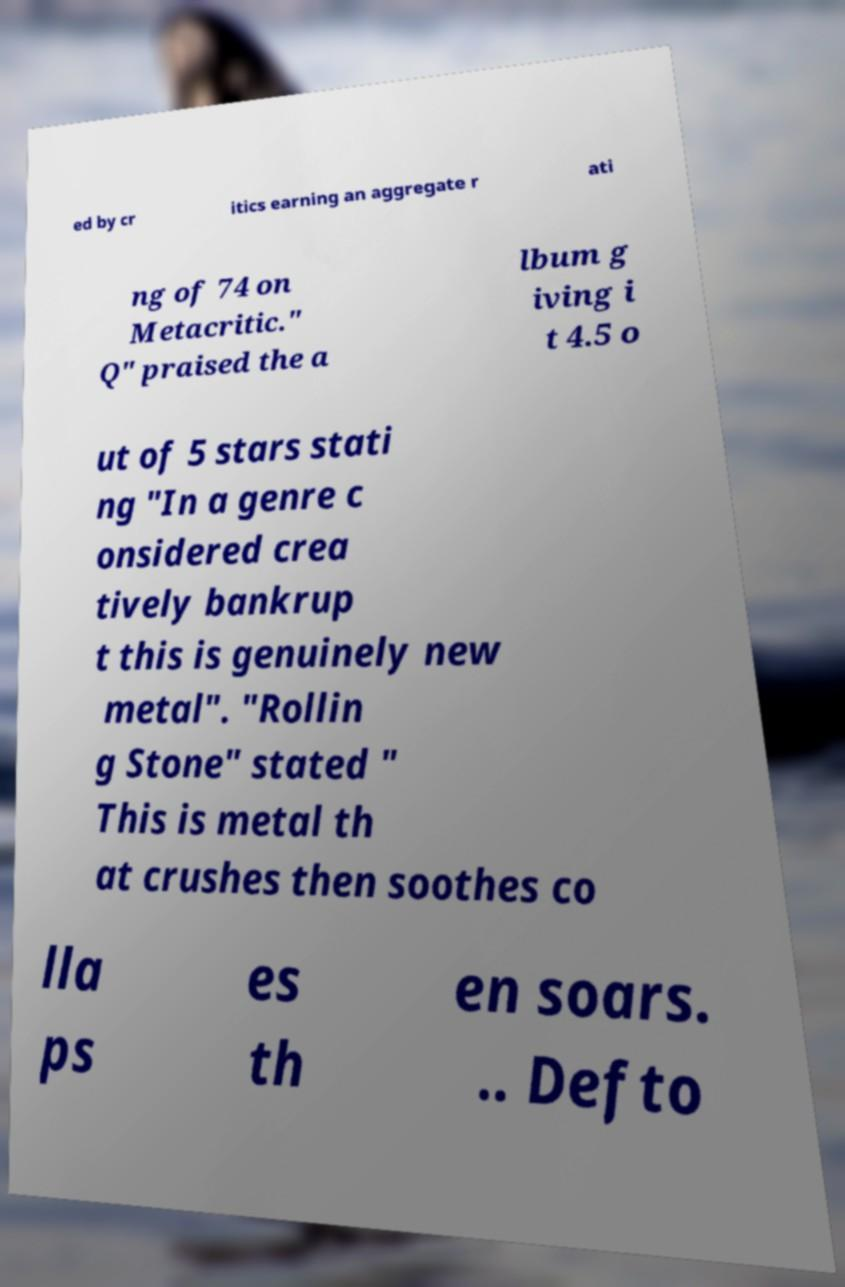Could you extract and type out the text from this image? ed by cr itics earning an aggregate r ati ng of 74 on Metacritic." Q" praised the a lbum g iving i t 4.5 o ut of 5 stars stati ng "In a genre c onsidered crea tively bankrup t this is genuinely new metal". "Rollin g Stone" stated " This is metal th at crushes then soothes co lla ps es th en soars. .. Defto 